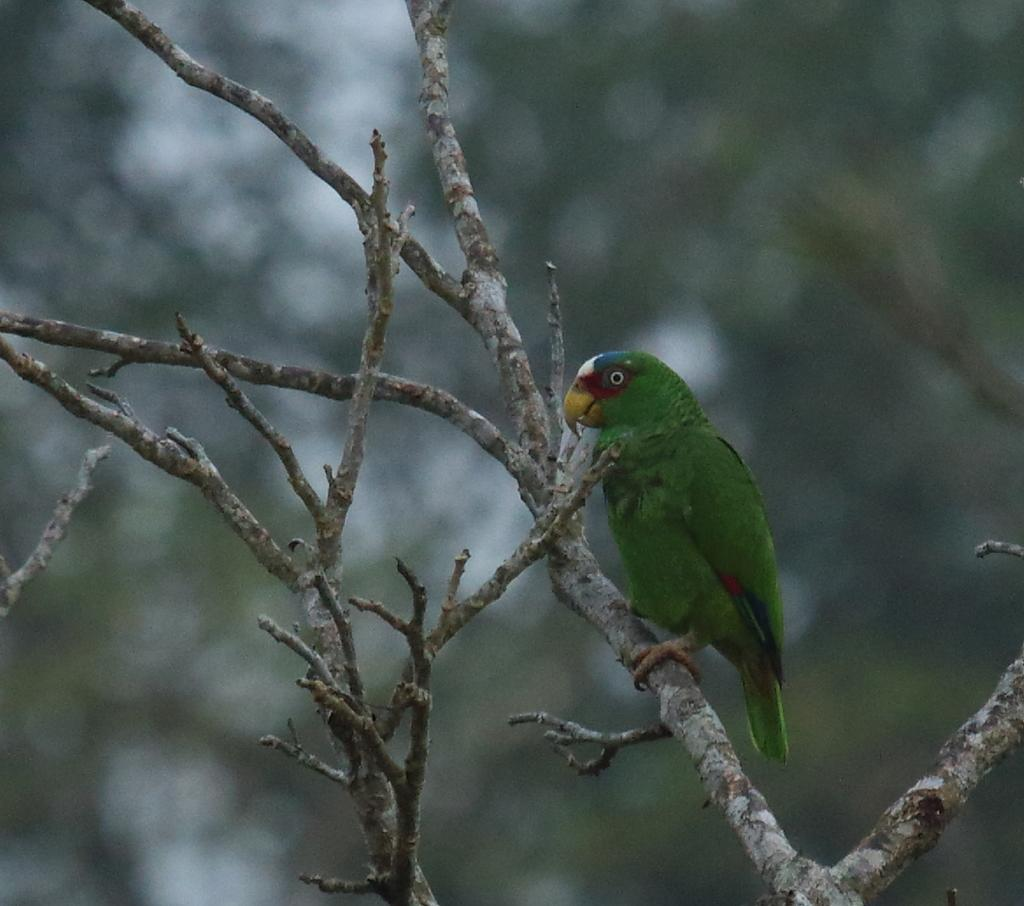What type of animal is in the image? There is a parrot in the image. What colors can be seen on the parrot? The parrot is green, red, and blue in color. Where is the parrot located in the image? The parrot is on a tree branch. Can you describe the background of the image? The background of the image is blurred. What type of business is being conducted in the image? There is no indication of any business being conducted in the image; it features a parrot on a tree branch. What type of beverage is being served in the image? There is no beverage present in the image, such as eggnog. 